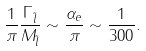Convert formula to latex. <formula><loc_0><loc_0><loc_500><loc_500>\frac { 1 } { \pi } \frac { \Gamma _ { \tilde { l } } } { M _ { \tilde { l } } } \sim \frac { \alpha _ { e } } { \pi } \sim \frac { 1 } { 3 0 0 } .</formula> 